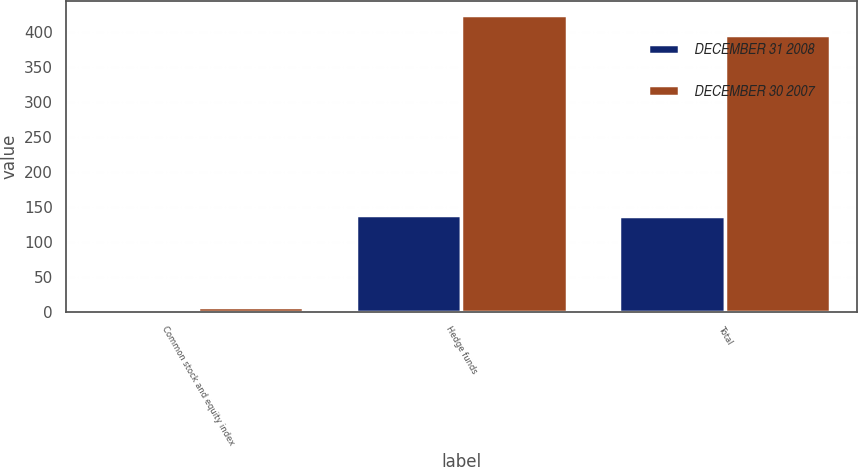Convert chart. <chart><loc_0><loc_0><loc_500><loc_500><stacked_bar_chart><ecel><fcel>Common stock and equity index<fcel>Hedge funds<fcel>Total<nl><fcel>DECEMBER 31 2008<fcel>2<fcel>138<fcel>136<nl><fcel>DECEMBER 30 2007<fcel>6<fcel>423<fcel>395<nl></chart> 